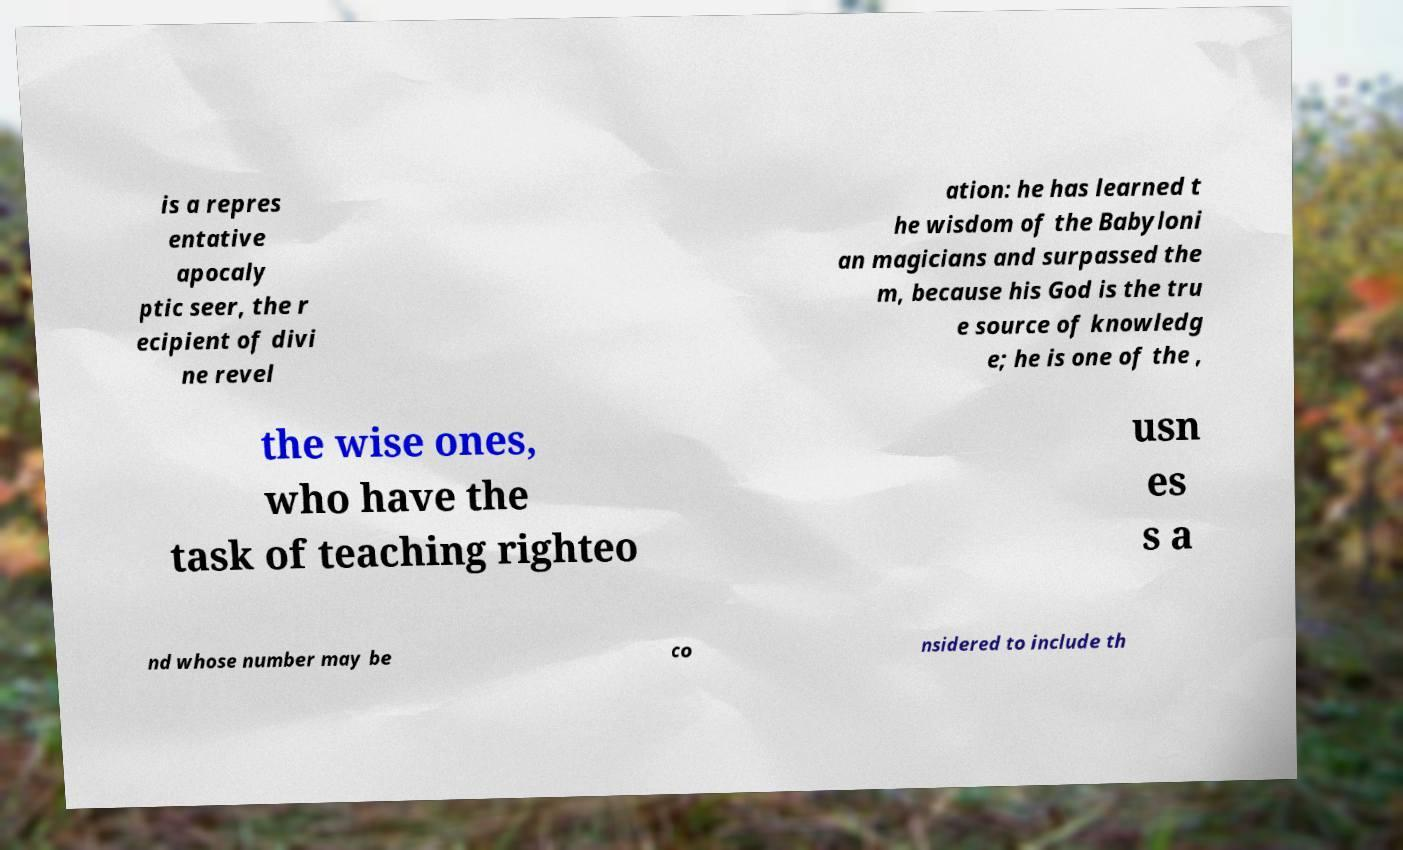Can you accurately transcribe the text from the provided image for me? is a repres entative apocaly ptic seer, the r ecipient of divi ne revel ation: he has learned t he wisdom of the Babyloni an magicians and surpassed the m, because his God is the tru e source of knowledg e; he is one of the , the wise ones, who have the task of teaching righteo usn es s a nd whose number may be co nsidered to include th 